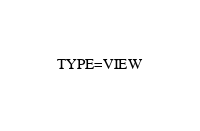Convert code to text. <code><loc_0><loc_0><loc_500><loc_500><_VisualBasic_>TYPE=VIEW</code> 